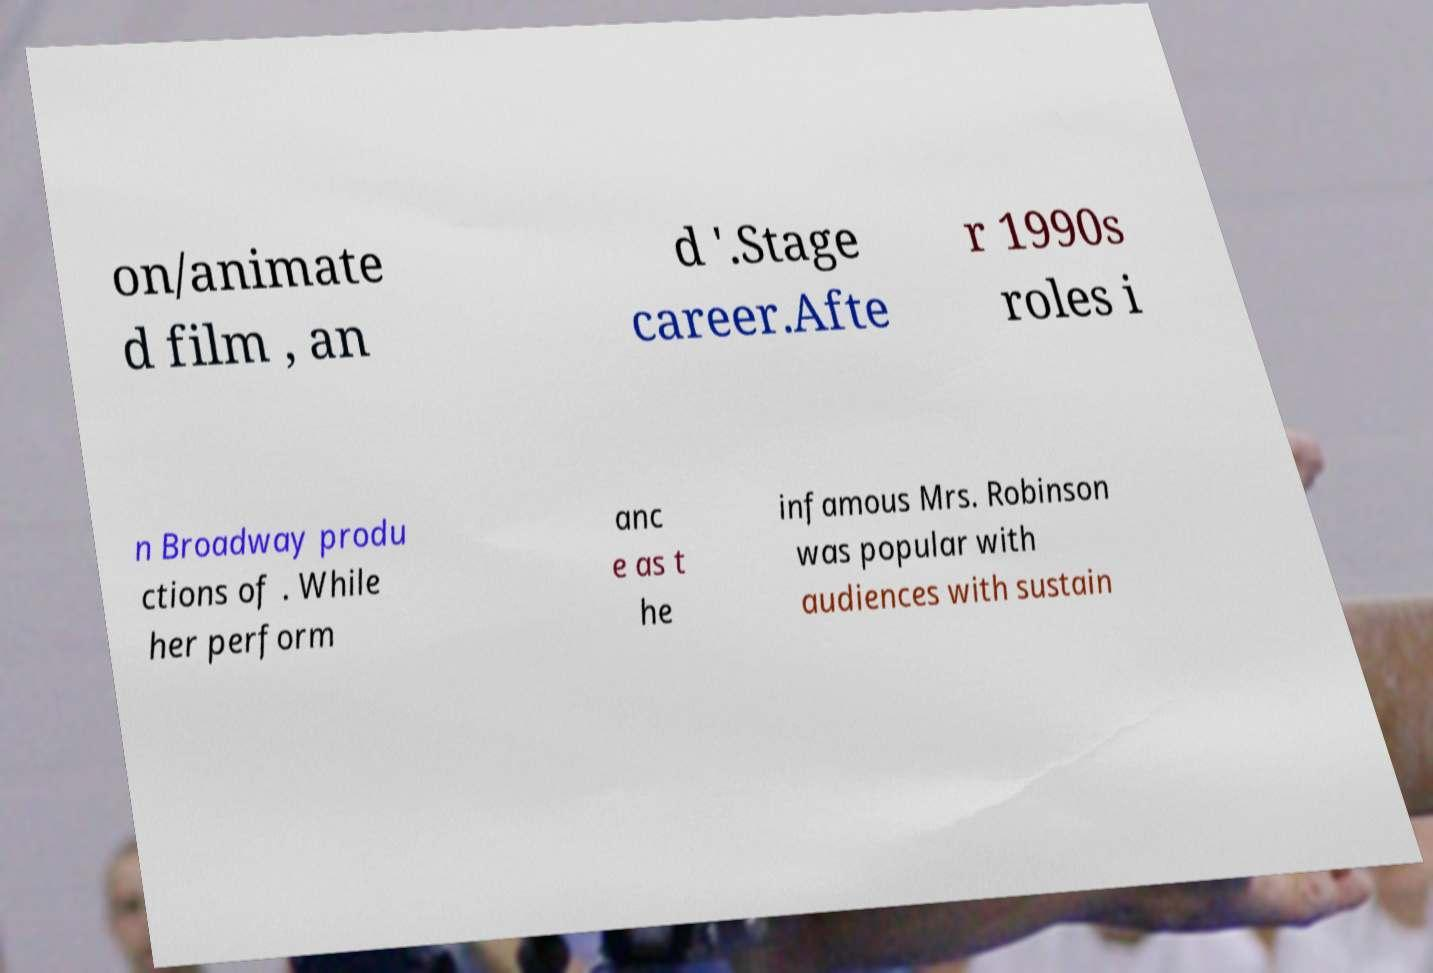Can you read and provide the text displayed in the image?This photo seems to have some interesting text. Can you extract and type it out for me? on/animate d film , an d '.Stage career.Afte r 1990s roles i n Broadway produ ctions of . While her perform anc e as t he infamous Mrs. Robinson was popular with audiences with sustain 